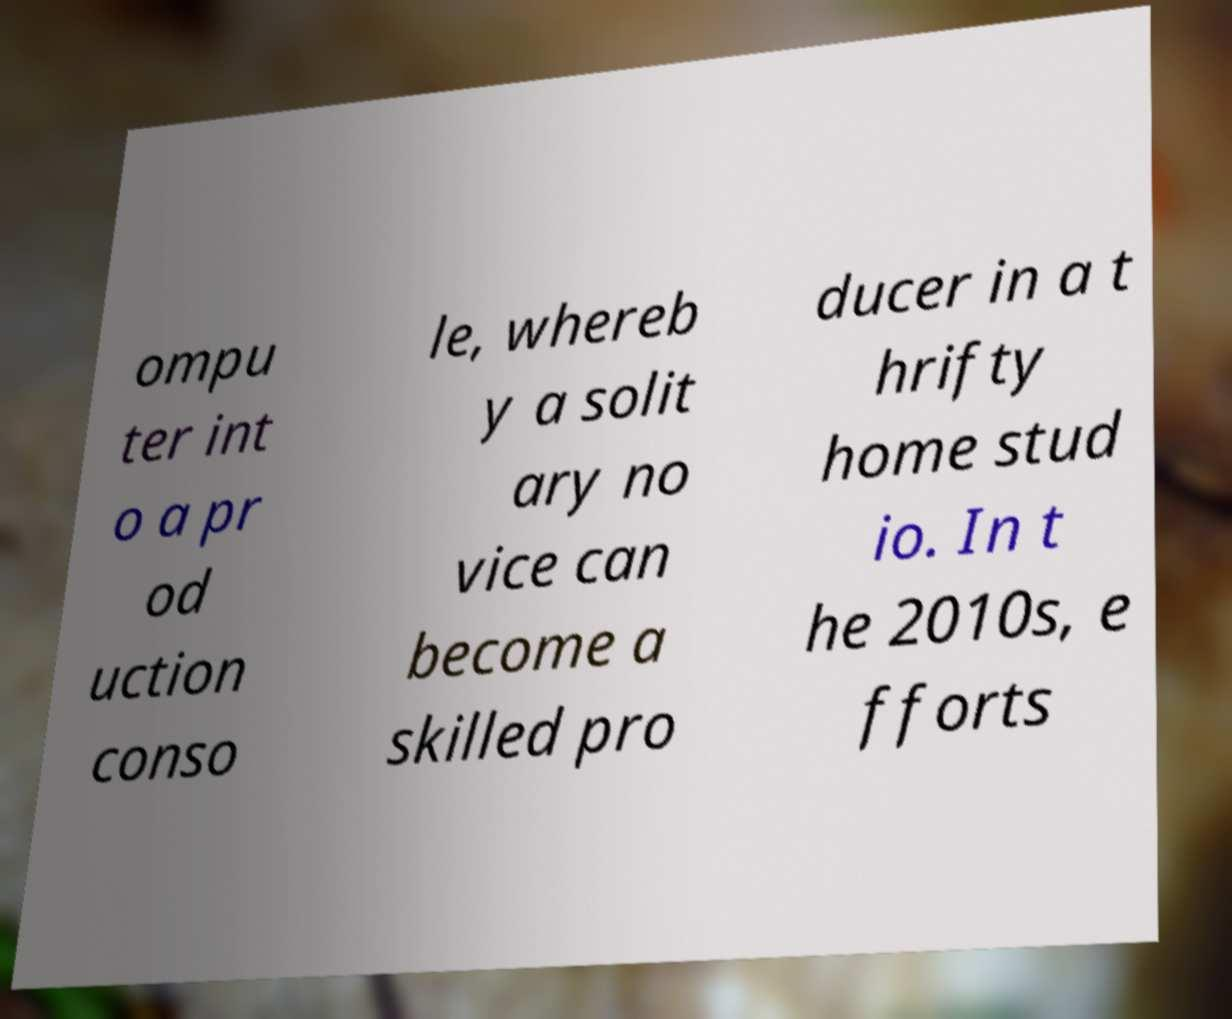For documentation purposes, I need the text within this image transcribed. Could you provide that? ompu ter int o a pr od uction conso le, whereb y a solit ary no vice can become a skilled pro ducer in a t hrifty home stud io. In t he 2010s, e fforts 